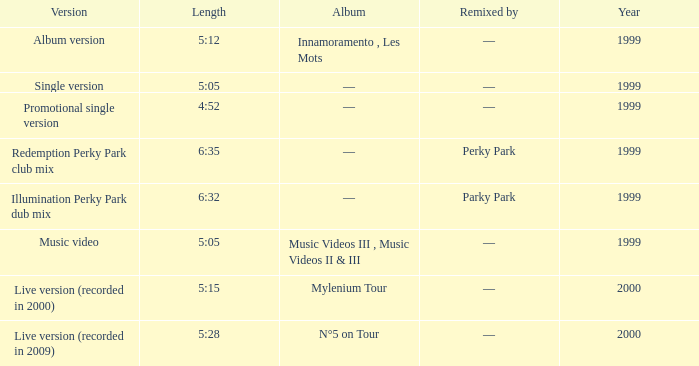What musical collection is 5 minutes and 15 seconds long? Live version (recorded in 2000). 